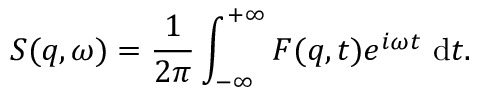Convert formula to latex. <formula><loc_0><loc_0><loc_500><loc_500>S ( q , \omega ) = \frac { 1 } { 2 \pi } \int _ { - \infty } ^ { + \infty } F ( q , t ) e ^ { i \omega t } d t .</formula> 